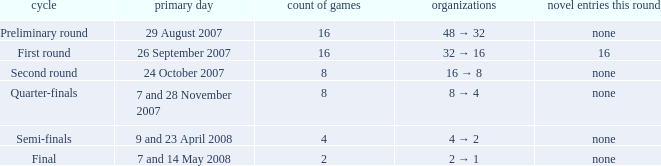What is the Clubs when there are 4 for the number of fixtures? 4 → 2. 